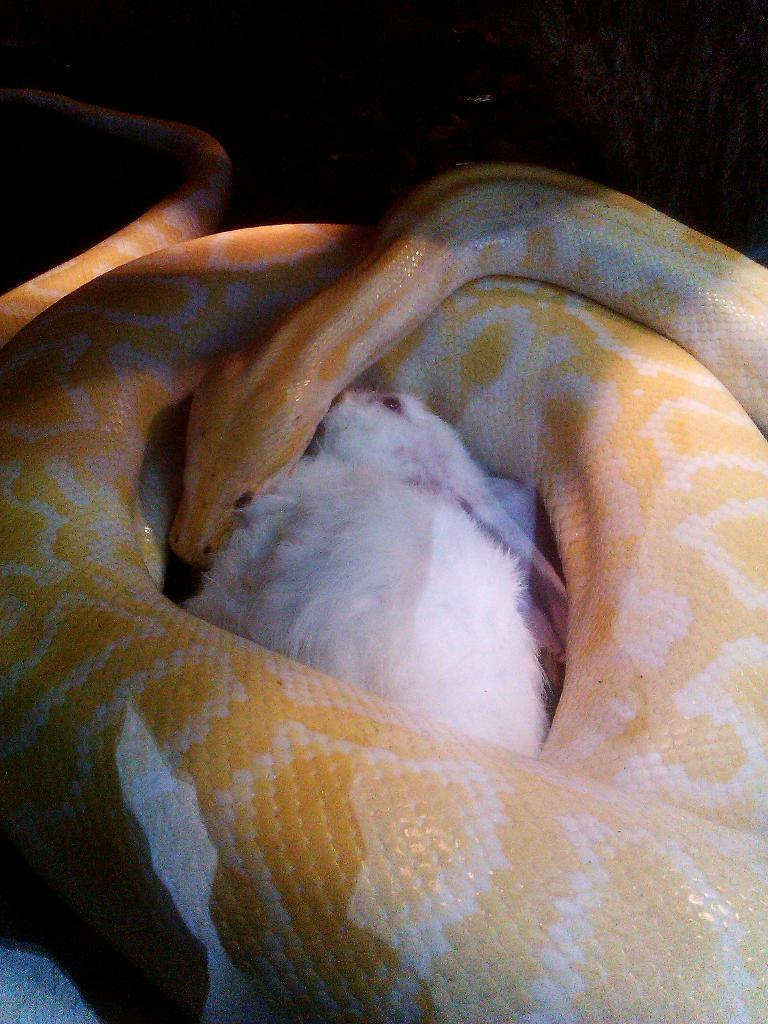What animals can be seen in the image? There is a snake and a rabbit in the image. Can you describe the appearance of the snake? The facts provided do not include a description of the snake's appearance. How are the animals positioned in relation to each other? The facts provided do not specify the positioning of the animals in relation to each other. What type of robin can be seen participating in a battle with the snake in the image? There is no robin or battle present in the image; it features a snake and a rabbit. 